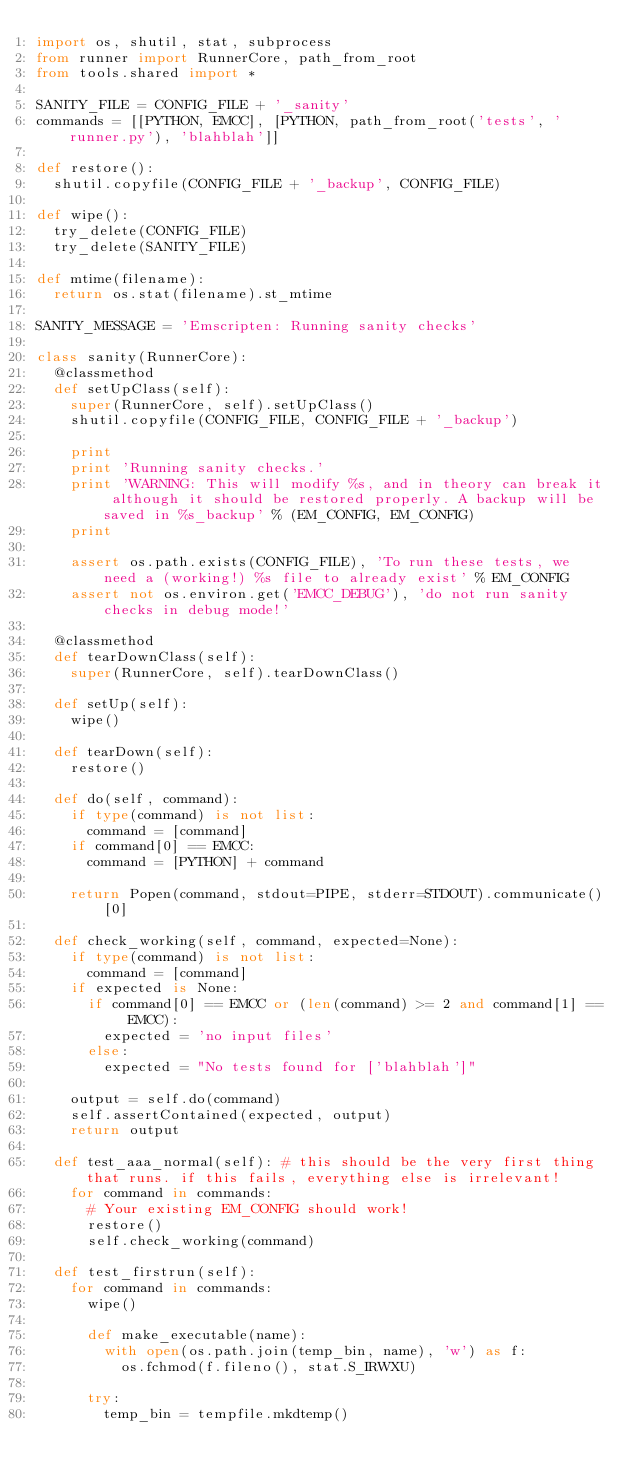<code> <loc_0><loc_0><loc_500><loc_500><_Python_>import os, shutil, stat, subprocess
from runner import RunnerCore, path_from_root
from tools.shared import *

SANITY_FILE = CONFIG_FILE + '_sanity'
commands = [[PYTHON, EMCC], [PYTHON, path_from_root('tests', 'runner.py'), 'blahblah']]

def restore():
  shutil.copyfile(CONFIG_FILE + '_backup', CONFIG_FILE)

def wipe():
  try_delete(CONFIG_FILE)
  try_delete(SANITY_FILE)

def mtime(filename):
  return os.stat(filename).st_mtime

SANITY_MESSAGE = 'Emscripten: Running sanity checks'

class sanity(RunnerCore):
  @classmethod
  def setUpClass(self):
    super(RunnerCore, self).setUpClass()
    shutil.copyfile(CONFIG_FILE, CONFIG_FILE + '_backup')

    print
    print 'Running sanity checks.'
    print 'WARNING: This will modify %s, and in theory can break it although it should be restored properly. A backup will be saved in %s_backup' % (EM_CONFIG, EM_CONFIG)
    print

    assert os.path.exists(CONFIG_FILE), 'To run these tests, we need a (working!) %s file to already exist' % EM_CONFIG
    assert not os.environ.get('EMCC_DEBUG'), 'do not run sanity checks in debug mode!'

  @classmethod
  def tearDownClass(self):
    super(RunnerCore, self).tearDownClass()

  def setUp(self):
    wipe()

  def tearDown(self):
    restore()

  def do(self, command):
    if type(command) is not list:
      command = [command]
    if command[0] == EMCC:
      command = [PYTHON] + command

    return Popen(command, stdout=PIPE, stderr=STDOUT).communicate()[0]

  def check_working(self, command, expected=None):
    if type(command) is not list:
      command = [command]
    if expected is None:
      if command[0] == EMCC or (len(command) >= 2 and command[1] == EMCC):
        expected = 'no input files'
      else:
        expected = "No tests found for ['blahblah']"

    output = self.do(command)
    self.assertContained(expected, output)
    return output

  def test_aaa_normal(self): # this should be the very first thing that runs. if this fails, everything else is irrelevant!
    for command in commands:
      # Your existing EM_CONFIG should work!
      restore()
      self.check_working(command)

  def test_firstrun(self):
    for command in commands:
      wipe()

      def make_executable(name):
        with open(os.path.join(temp_bin, name), 'w') as f:
          os.fchmod(f.fileno(), stat.S_IRWXU)

      try:
        temp_bin = tempfile.mkdtemp()</code> 